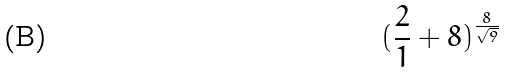Convert formula to latex. <formula><loc_0><loc_0><loc_500><loc_500>( \frac { 2 } { 1 } + 8 ) ^ { \frac { 8 } { \sqrt { 9 } } }</formula> 